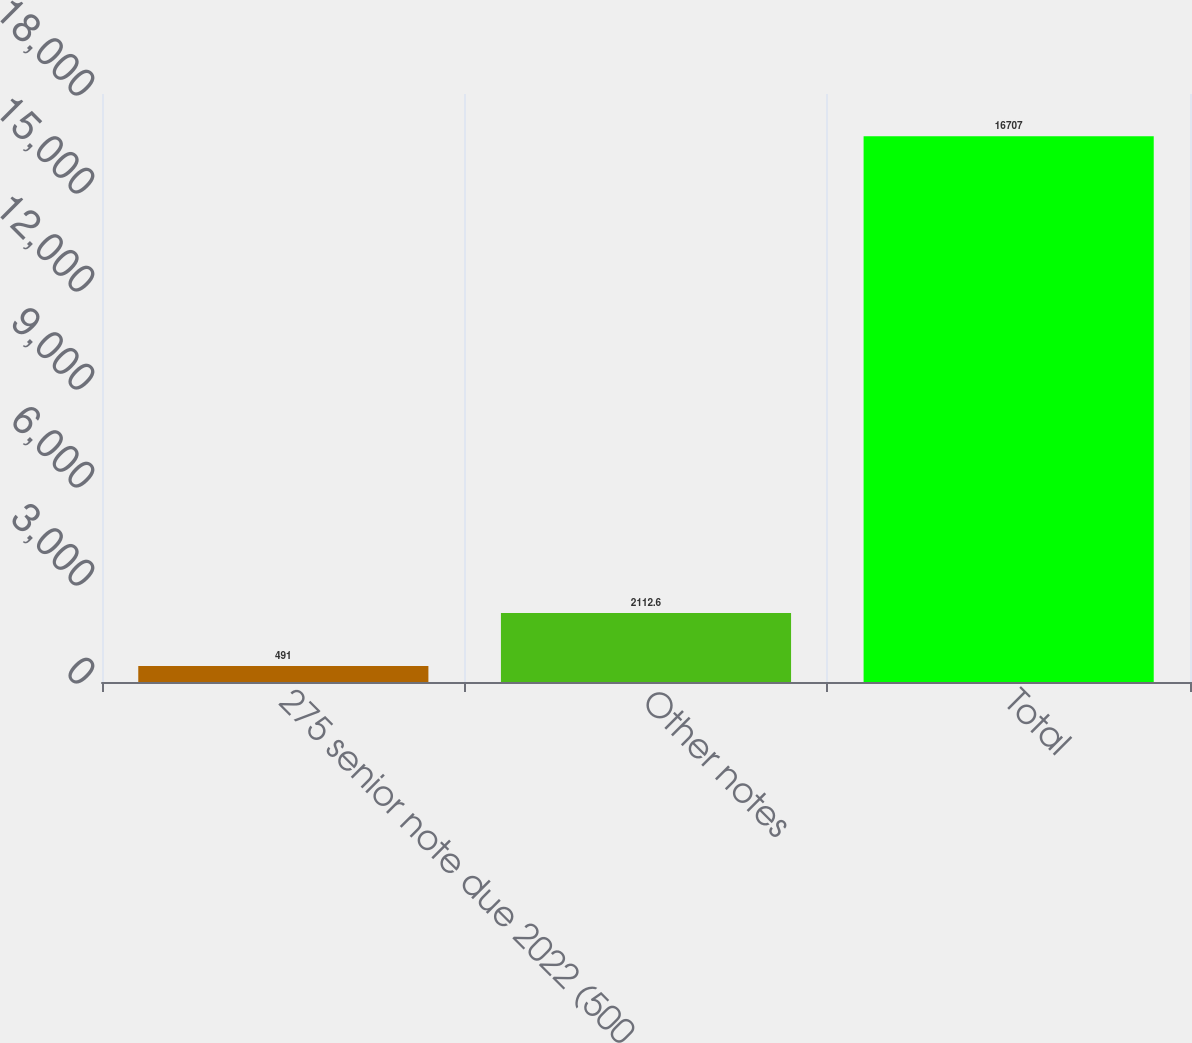<chart> <loc_0><loc_0><loc_500><loc_500><bar_chart><fcel>275 senior note due 2022 (500<fcel>Other notes<fcel>Total<nl><fcel>491<fcel>2112.6<fcel>16707<nl></chart> 